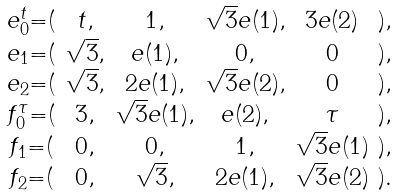<formula> <loc_0><loc_0><loc_500><loc_500>\begin{smallmatrix} e _ { 0 } ^ { t } = ( & t , & 1 , & \sqrt { 3 } e ( 1 ) , & 3 e ( 2 ) & ) , \\ e _ { 1 } = ( & \sqrt { 3 } , & e ( 1 ) , & 0 , & 0 & ) , \\ e _ { 2 } = ( & \sqrt { 3 } , & 2 e ( 1 ) , & \sqrt { 3 } e ( 2 ) , & 0 & ) , \\ f _ { 0 } ^ { \tau } = ( & 3 , & \sqrt { 3 } e ( 1 ) , & e ( 2 ) , & \tau & ) , \\ f _ { 1 } = ( & 0 , & 0 , & 1 , & \sqrt { 3 } e ( 1 ) & ) , \\ f _ { 2 } = ( & 0 , & \sqrt { 3 } , & 2 e ( 1 ) , & \sqrt { 3 } e ( 2 ) & ) . \\ \end{smallmatrix}</formula> 